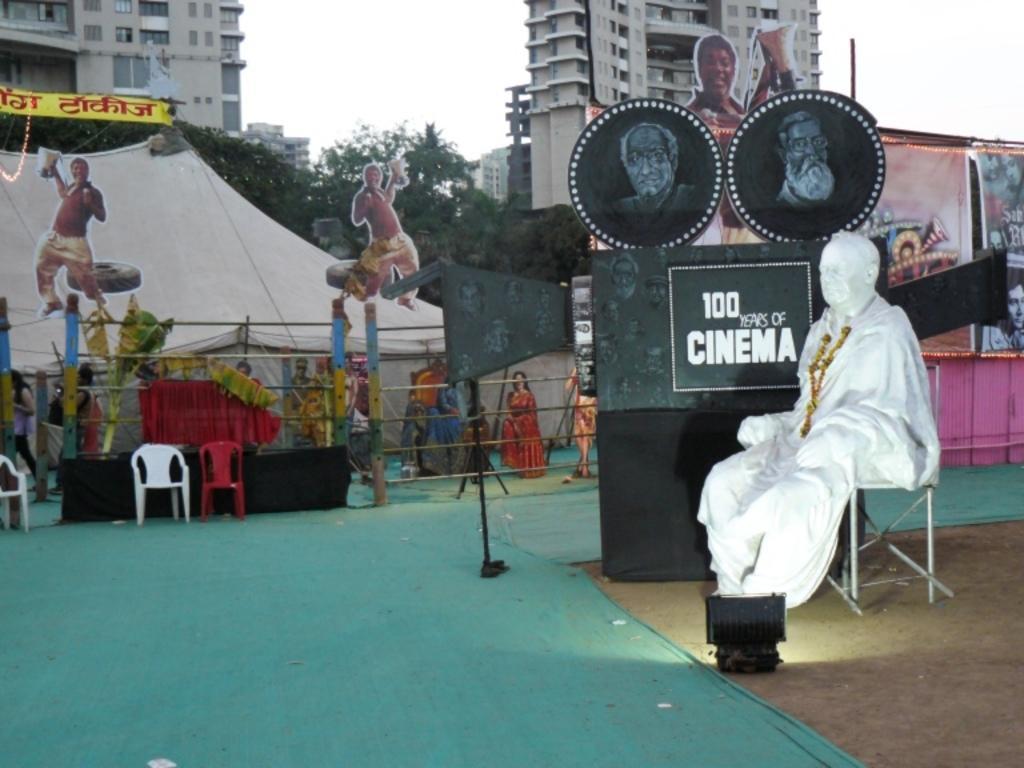Can you describe this image briefly? In this image we can see a statue with a garland sitting on a chair. On the backside we can see a green carpet, camera with a stand, chairs, stage, fence, pictures, trees, a building and the sky. 